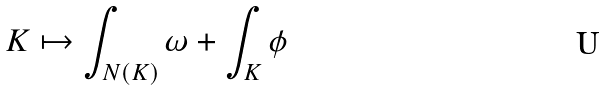Convert formula to latex. <formula><loc_0><loc_0><loc_500><loc_500>K \mapsto \int _ { N ( K ) } \omega + \int _ { K } \phi</formula> 